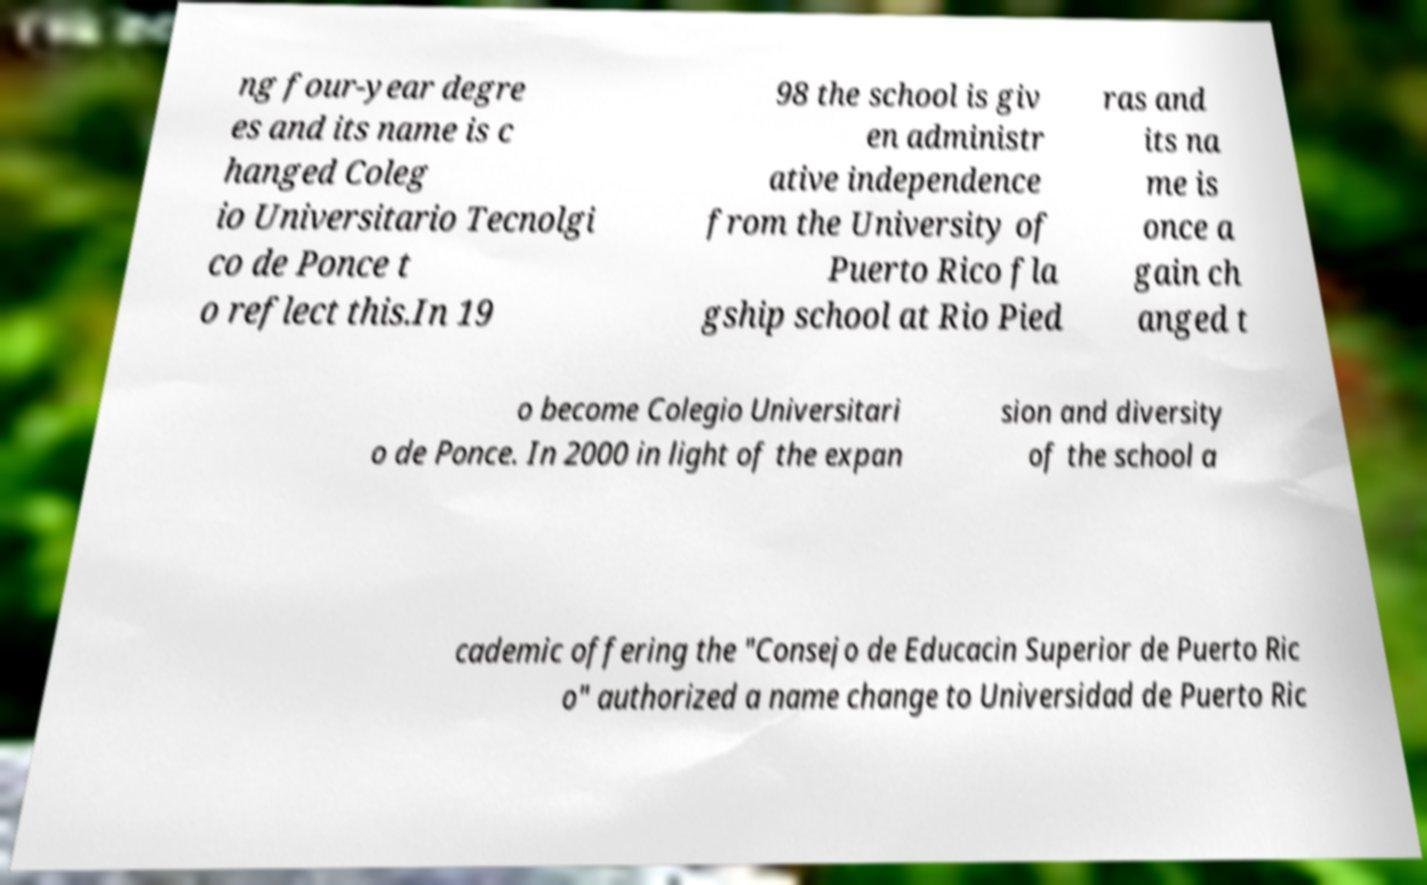Please identify and transcribe the text found in this image. ng four-year degre es and its name is c hanged Coleg io Universitario Tecnolgi co de Ponce t o reflect this.In 19 98 the school is giv en administr ative independence from the University of Puerto Rico fla gship school at Rio Pied ras and its na me is once a gain ch anged t o become Colegio Universitari o de Ponce. In 2000 in light of the expan sion and diversity of the school a cademic offering the "Consejo de Educacin Superior de Puerto Ric o" authorized a name change to Universidad de Puerto Ric 